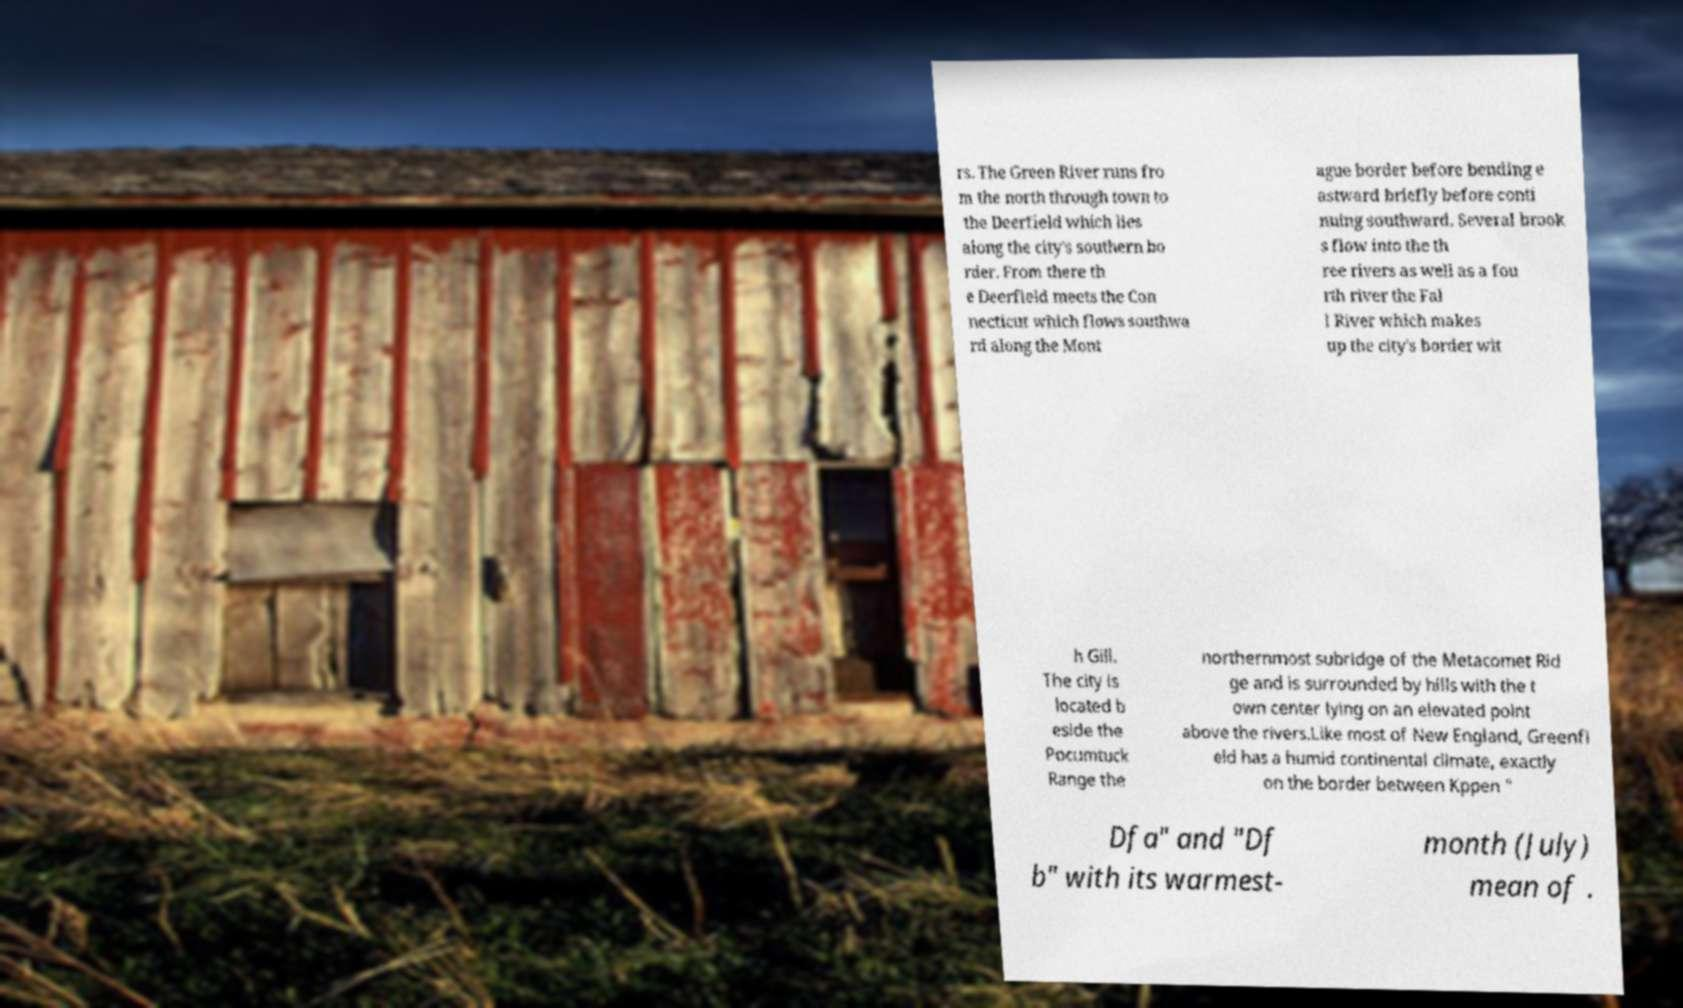There's text embedded in this image that I need extracted. Can you transcribe it verbatim? rs. The Green River runs fro m the north through town to the Deerfield which lies along the city's southern bo rder. From there th e Deerfield meets the Con necticut which flows southwa rd along the Mont ague border before bending e astward briefly before conti nuing southward. Several brook s flow into the th ree rivers as well as a fou rth river the Fal l River which makes up the city's border wit h Gill. The city is located b eside the Pocumtuck Range the northernmost subridge of the Metacomet Rid ge and is surrounded by hills with the t own center lying on an elevated point above the rivers.Like most of New England, Greenfi eld has a humid continental climate, exactly on the border between Kppen " Dfa" and "Df b" with its warmest- month (July) mean of . 